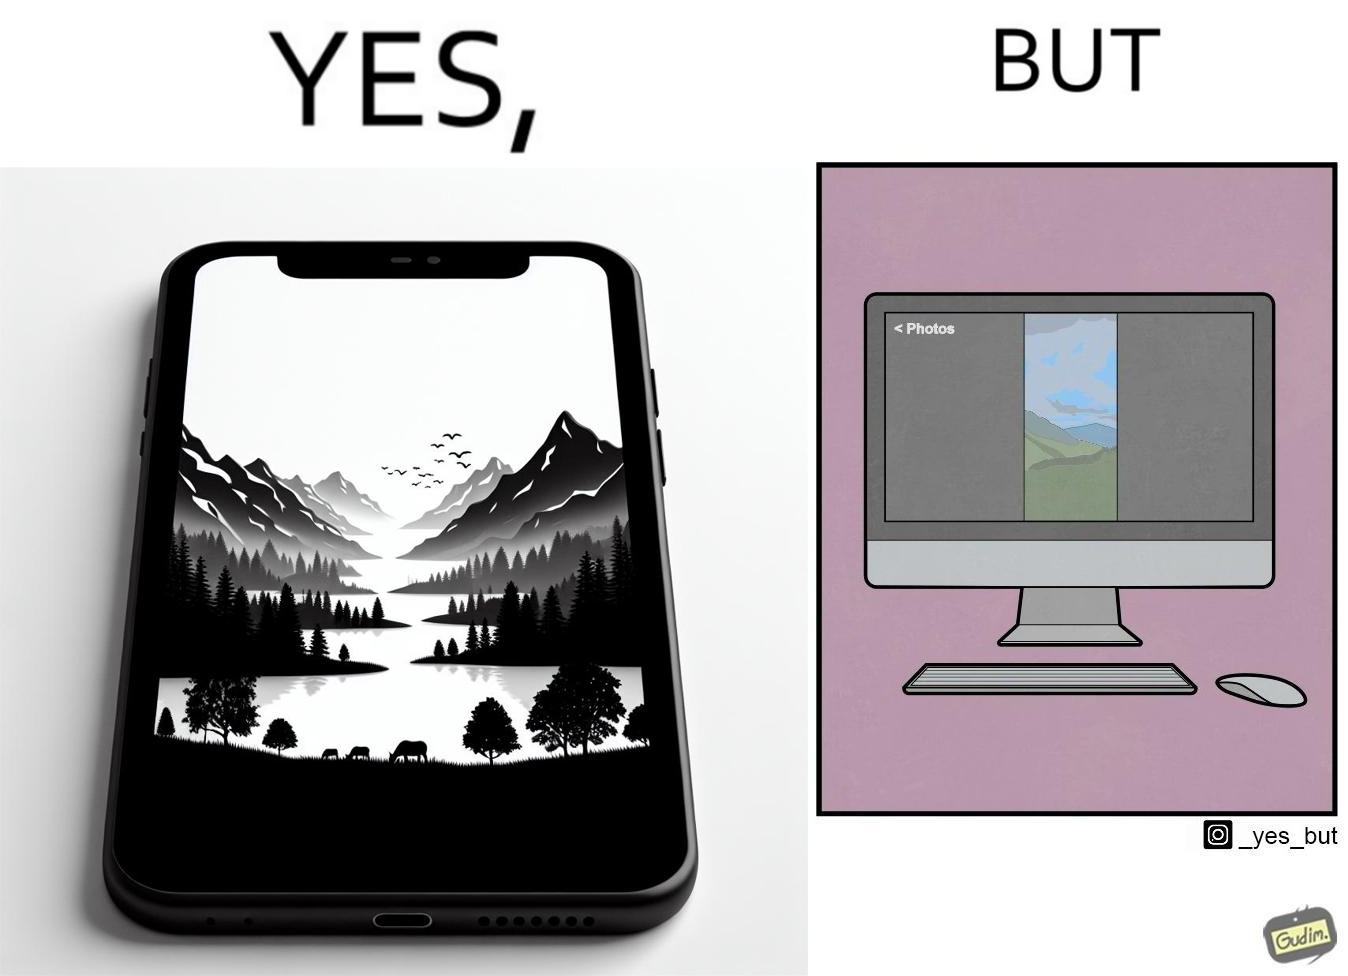Explain why this image is satirical. This image is funny, as when using the "photos" app on mobile, it shows you images perfectly, which fill the entire screen, but when viewing the same photos on the computer monitor, the same images have a very limited coverage of the screen. 